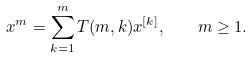<formula> <loc_0><loc_0><loc_500><loc_500>x ^ { m } = \sum ^ { m } _ { k = 1 } T ( m , k ) x ^ { [ k ] } , \quad m \geq 1 .</formula> 